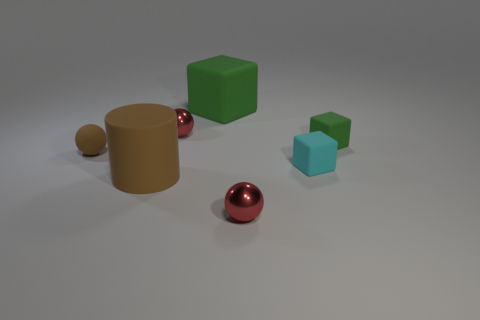Add 3 tiny purple shiny blocks. How many objects exist? 10 Subtract all cylinders. How many objects are left? 6 Subtract all small green cubes. Subtract all tiny metal things. How many objects are left? 4 Add 3 large matte objects. How many large matte objects are left? 5 Add 1 large green matte objects. How many large green matte objects exist? 2 Subtract 0 green cylinders. How many objects are left? 7 